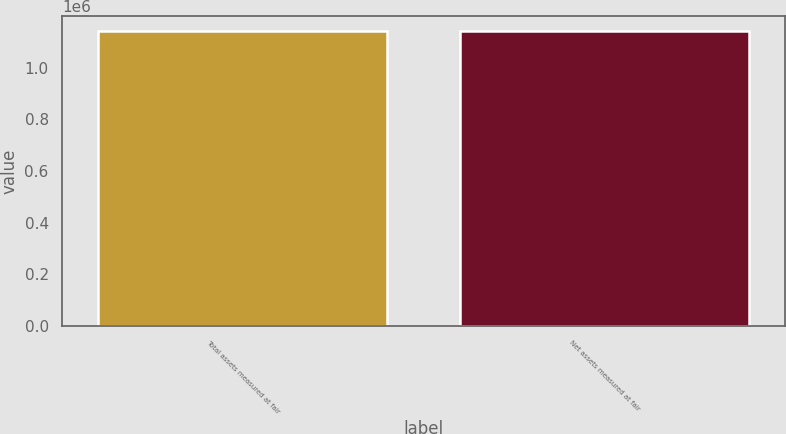Convert chart to OTSL. <chart><loc_0><loc_0><loc_500><loc_500><bar_chart><fcel>Total assets measured at fair<fcel>Net assets measured at fair<nl><fcel>1.14216e+06<fcel>1.14108e+06<nl></chart> 